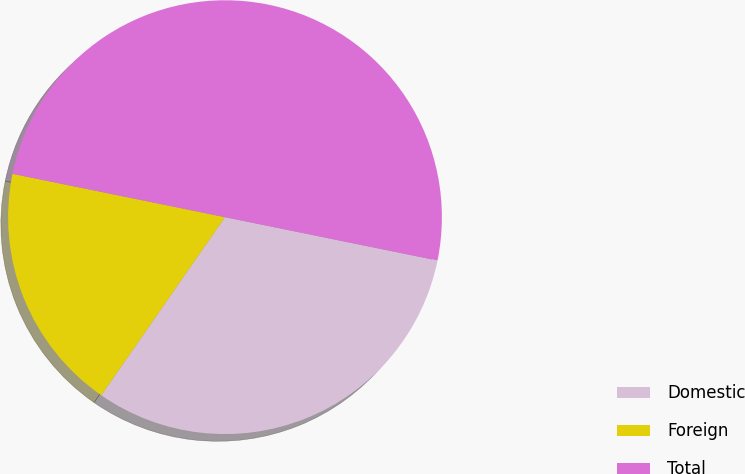Convert chart. <chart><loc_0><loc_0><loc_500><loc_500><pie_chart><fcel>Domestic<fcel>Foreign<fcel>Total<nl><fcel>31.46%<fcel>18.54%<fcel>50.0%<nl></chart> 